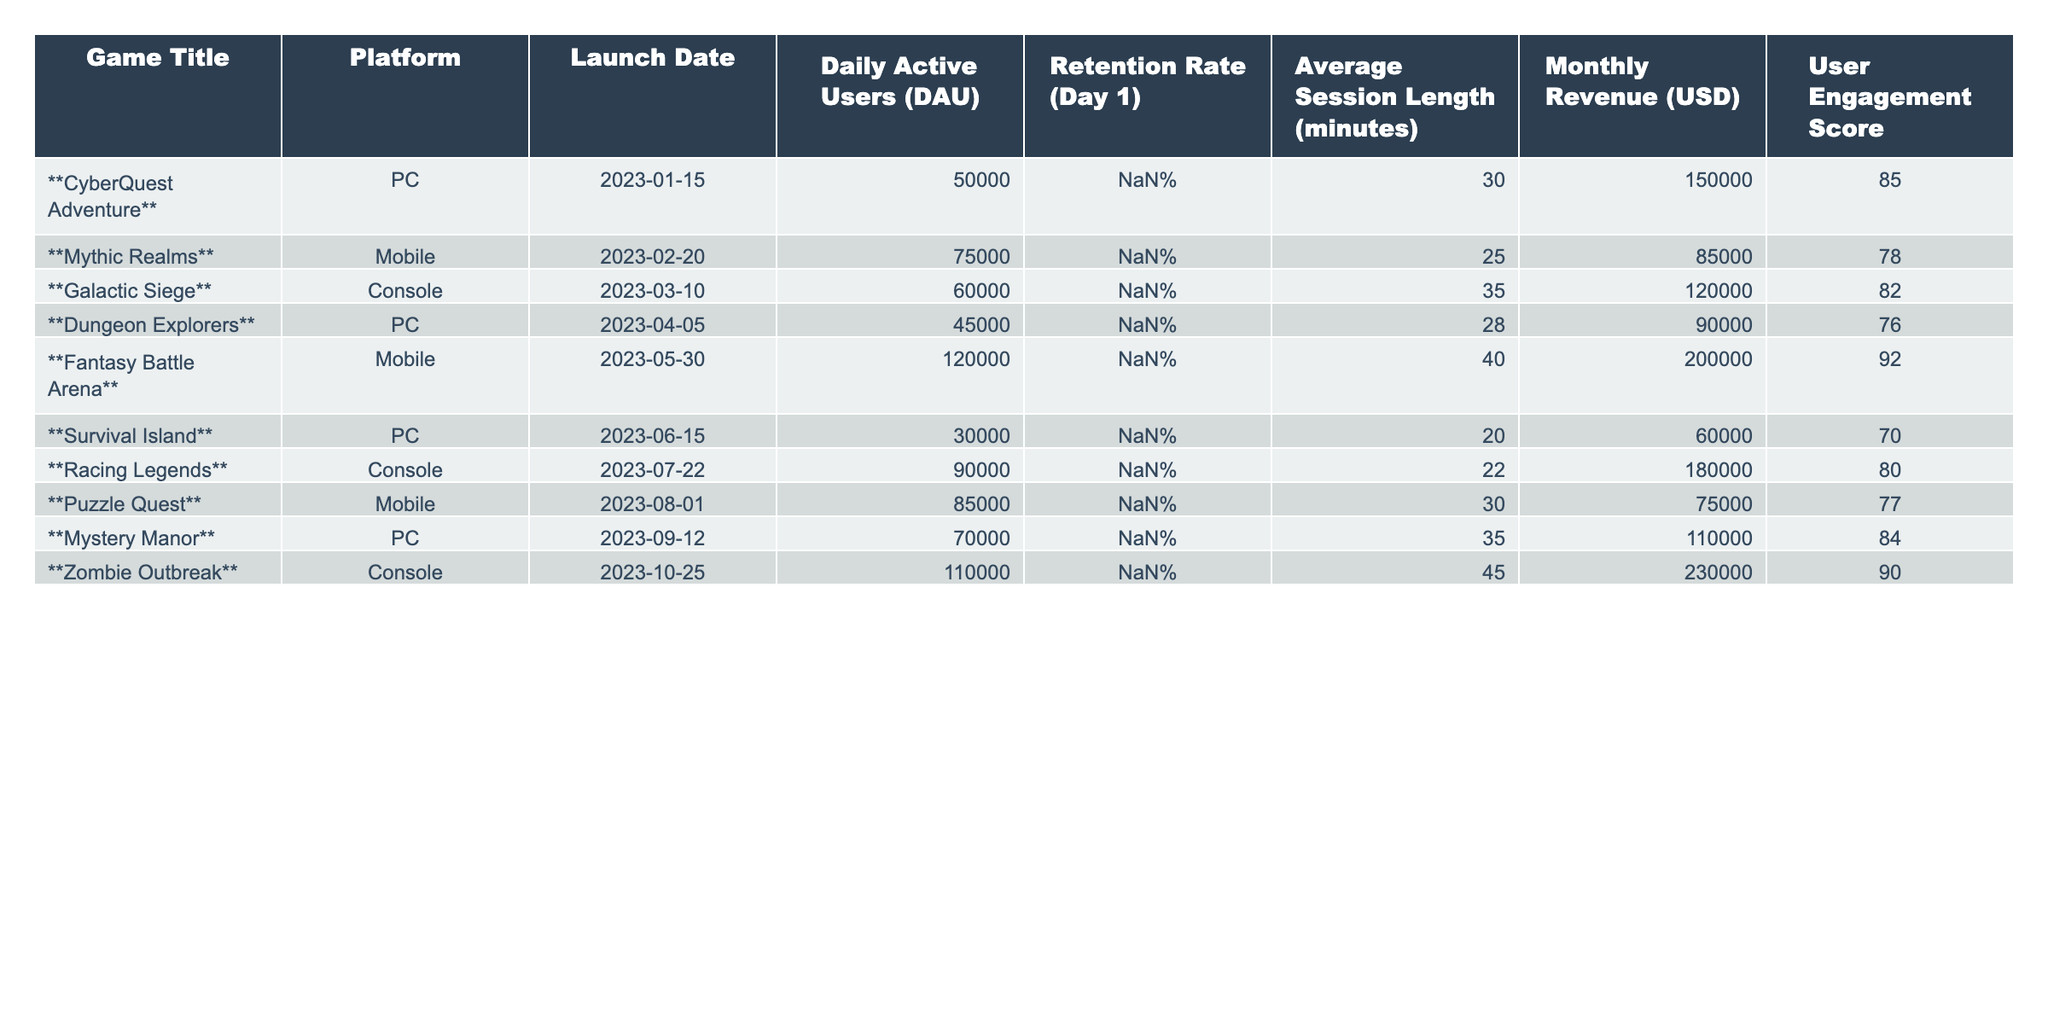What is the retention rate for Fantasy Battle Arena? The table shows a retention rate of 60% for Fantasy Battle Arena, which is directly listed under the "Retention Rate" column.
Answer: 60% Which game has the highest Daily Active Users (DAU)? By comparing the DAU values in the table, Fantasy Battle Arena has the highest figure at 120,000 users.
Answer: Fantasy Battle Arena What is the average session length for the games launched on PC? The average session lengths for PC games (CyberQuest Adventure, Dungeon Explorers, Survival Island, Mystery Manor) are 30, 28, 20, and 35 minutes respectively. Summing these gives 113 minutes, and dividing by 4 (the number of PC games) results in an average session length of 28.25 minutes.
Answer: 28.25 minutes Is the Monthly Revenue for Zombie Outbreak greater than that of Mythis Realms? The Monthly Revenue for Zombie Outbreak is $230,000 while for Mythic Realms it is $85,000. Since $230,000 is greater than $85,000, the statement is true.
Answer: Yes What is the User Engagement Score difference between CyberQuest Adventure and Survival Island? CyberQuest Adventure has an engagement score of 85 while Survival Island has a score of 70. Their difference is calculated as 85 - 70 = 15.
Answer: 15 Which platform has the lowest Average Session Length? Comparing the Average Session Lengths, Survival Island has the lowest at 20 minutes; this value is listed under the "Average Session Length" column.
Answer: PC What is the total Monthly Revenue for all Mobile games? From the table, the Monthly Revenues for Mobile games (Mythic Realms, Fantasy Battle Arena, Puzzle Quest) are $85,000, $200,000, and $75,000. Summing these gives $85,000 + $200,000 + $75,000 = $360,000.
Answer: $360,000 Which game was launched first, Mythic Realms or Galactic Siege? By comparing the Launch Dates of both games, Mythic Realms (February 20, 2023) was launched before Galactic Siege (March 10, 2023).
Answer: Mythic Realms What is the average retention rate for all console games? The retention rates for console games (Galactic Siege, Racing Legends, Zombie Outbreak) are 50%, 50%, and 62% respectively. The average is calculated as (50% + 50% + 62%) / 3 = 54%.
Answer: 54% Is there any game that has a User Engagement Score of 92 or higher? Yes, Fantasy Battle Arena has a User Engagement Score of 92, which meets the criteria.
Answer: Yes 